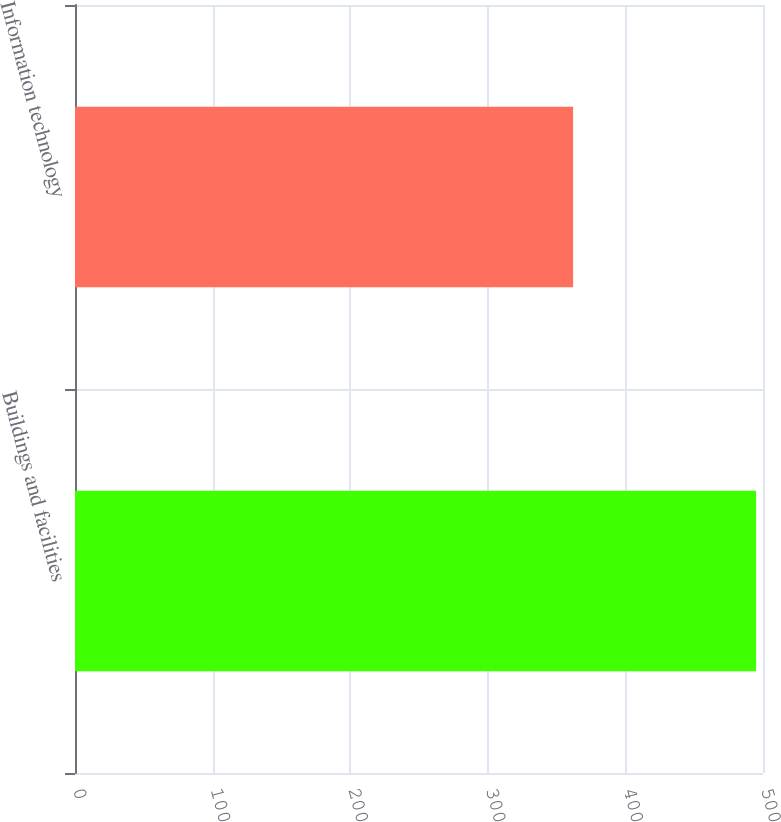<chart> <loc_0><loc_0><loc_500><loc_500><bar_chart><fcel>Buildings and facilities<fcel>Information technology<nl><fcel>495<fcel>362<nl></chart> 